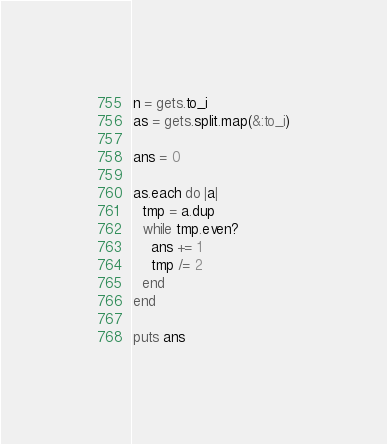<code> <loc_0><loc_0><loc_500><loc_500><_Ruby_>n = gets.to_i
as = gets.split.map(&:to_i)

ans = 0

as.each do |a|
  tmp = a.dup
  while tmp.even?
    ans += 1
    tmp /= 2
  end
end

puts ans
</code> 